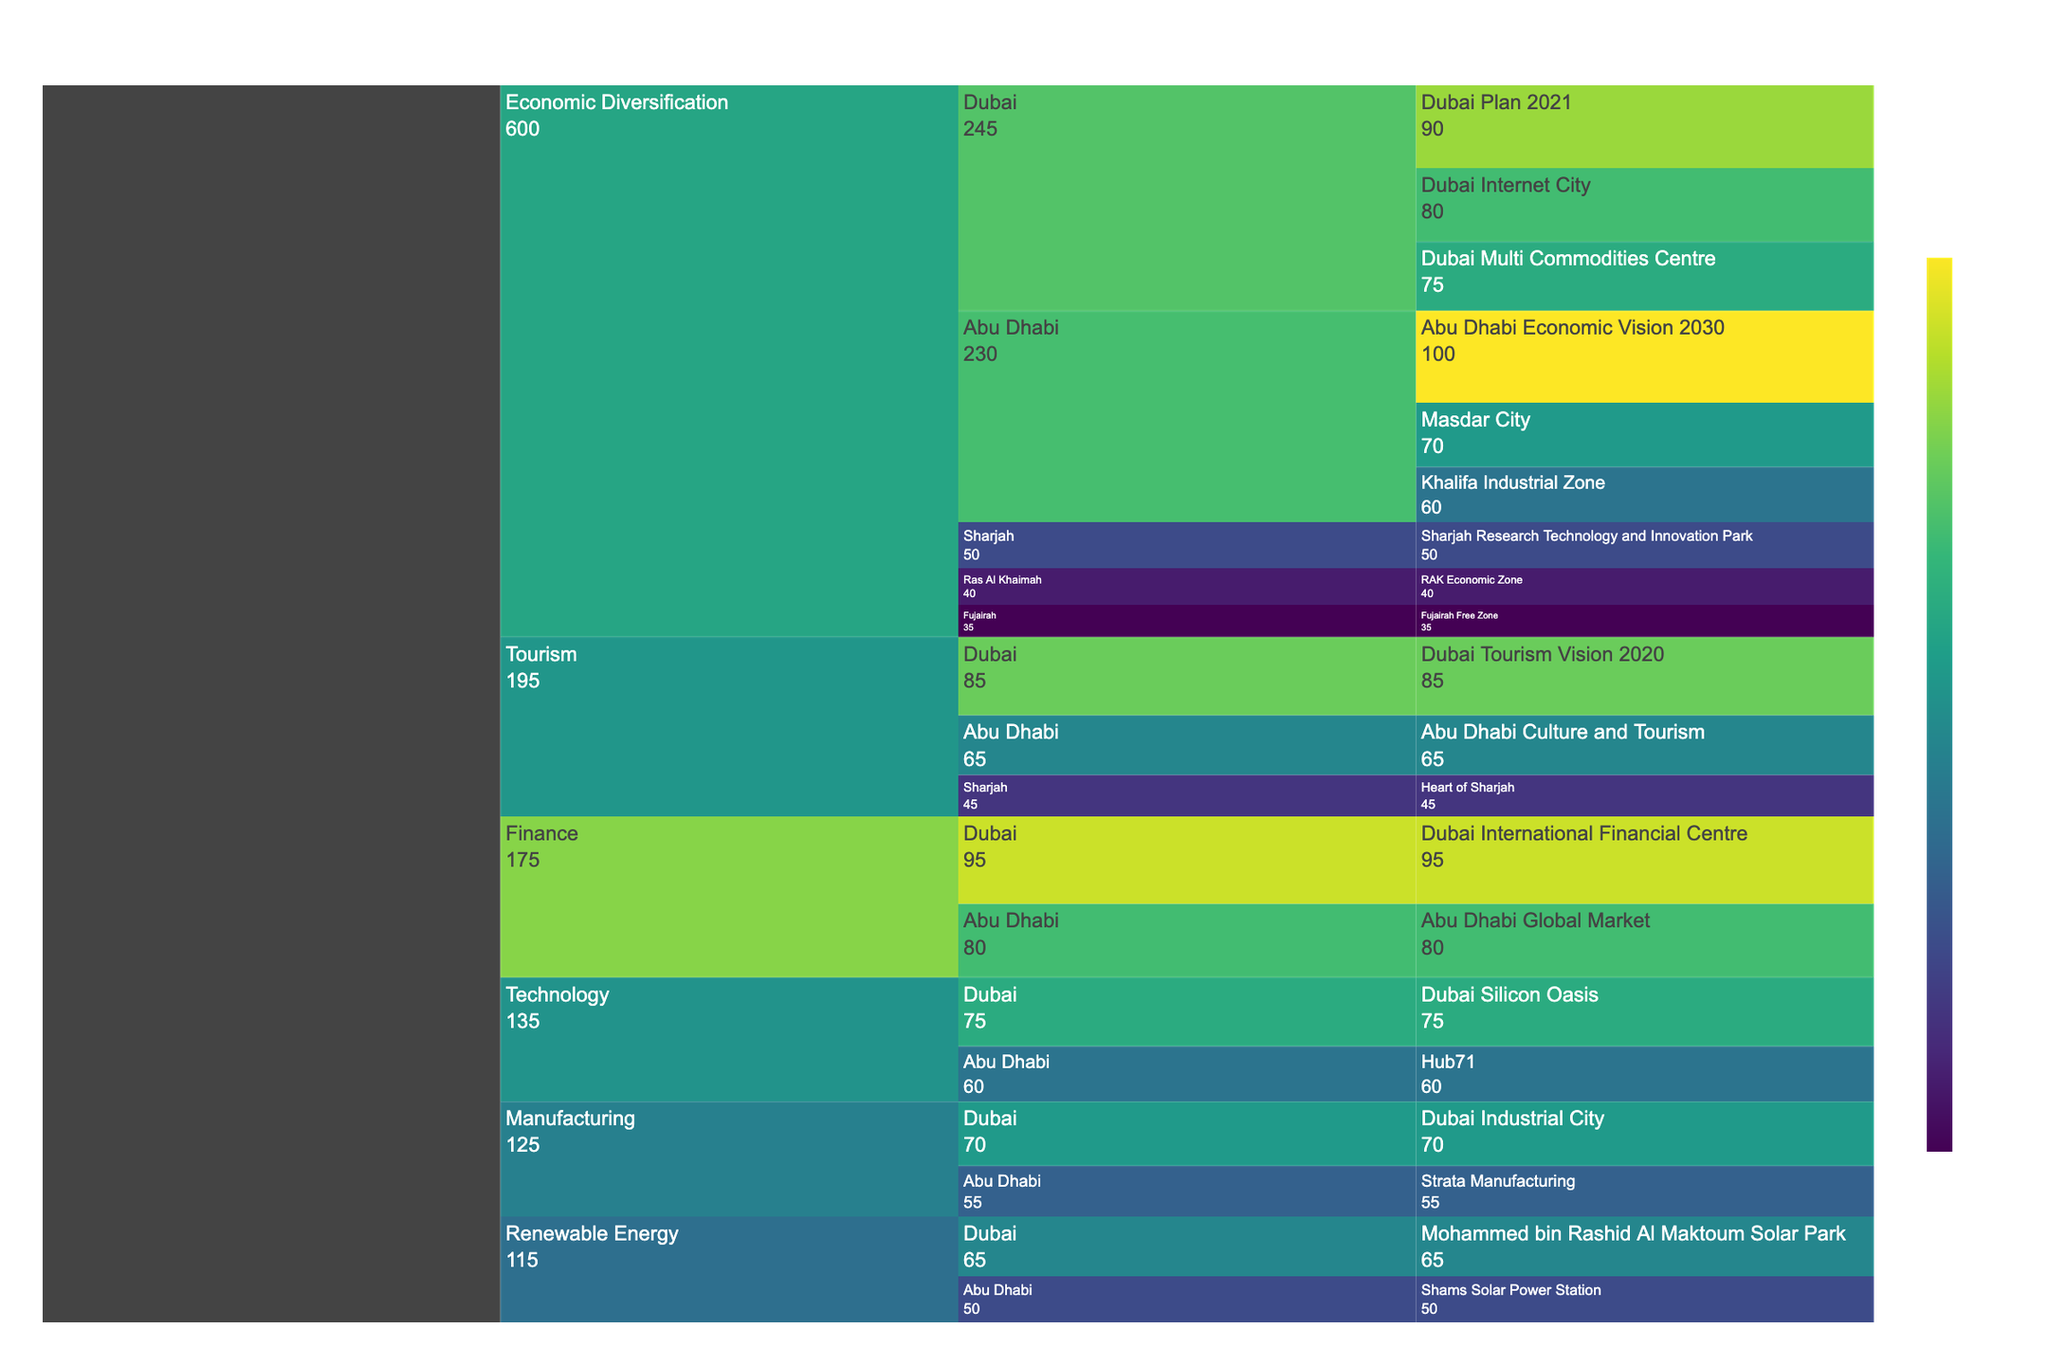What is the title of the chart? The title of the chart is usually positioned at the top center. From the code, we see it's defined as 'UAE Economic Diversification Efforts'.
Answer: UAE Economic Diversification Efforts Which emirate has the highest value in the economic diversification sector? To find the emirate with the highest value, look at the breakdown within the Economic Diversification sector and sum the values for each emirate. Abu Dhabi's total is 230, Dubai's total is 245, Sharjah has 50, Ras Al Khaimah has 40, and Fujairah has 35. Dubai has the highest total value.
Answer: Dubai What initiative contributes the most significant value in the finance sector? Examining the finance sector within the chart, we look for the highest single initiative value. Dubai's 'Dubai International Financial Centre' has a value of 95, while Abu Dhabi's 'Abu Dhabi Global Market' has a value of 80. Thus, the highest value is from Dubai International Financial Centre.
Answer: Dubai International Financial Centre Which sector has the most initiatives listed? To determine the sector with the most initiatives, count the initiatives under each sector. Economic Diversification has the initiatives: Abu Dhabi Economic Vision 2030, Masdar City, Khalifa Industrial Zone, Dubai Plan 2021, Dubai Internet City, Dubai Multi Commodities Centre, Sharjah Research Technology and Innovation Park, RAK Economic Zone, and Fujairah Free Zone, totalling 9. Other sectors have fewer initiatives.
Answer: Economic Diversification What is the cumulative value for the Renewable Energy sector? For cumulative value, sum all values in the Renewable Energy sector. Abu Dhabi's 'Shams Solar Power Station' is 50, and Dubai's 'Mohammed bin Rashid Al Maktoum Solar Park' is 65, so 50 + 65 = 115.
Answer: 115 Which emirate has initiatives across the most different sectors? To determine the emirate with initiatives in the most sectors, count the sectors represented for each emirate. Abu Dhabi is in Economic Diversification, Tourism, Finance, Manufacturing, Technology, and Renewable Energy, spanning 6 sectors. Dubai also covers 6 sectors.
Answer: Abu Dhabi and Dubai What is the difference in value between Dubai's Dubai International Financial Centre and Abu Dhabi's Abu Dhabi Global Market? The value of Dubai International Financial Centre is 95, and the value of Abu Dhabi Global Market is 80. The difference is 95 - 80 = 15.
Answer: 15 Which sector has the highest total value, and what is that value? Sum the values in each sector. Economic Diversification: 230 + 245 + 50 + 40 + 35 = 600, Tourism: 85 + 65 + 45 = 195, Finance: 95 + 80 = 175, Manufacturing: 55 + 70 = 125, Technology: 75 + 60 = 135, Renewable Energy: 50 + 65 = 115. Economic Diversification has the highest total, 600.
Answer: Economic Diversification, 600 